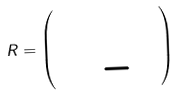<formula> <loc_0><loc_0><loc_500><loc_500>R = \left ( \begin{array} { r r } 1 & 0 \\ 0 & - 1 \end{array} \right )</formula> 